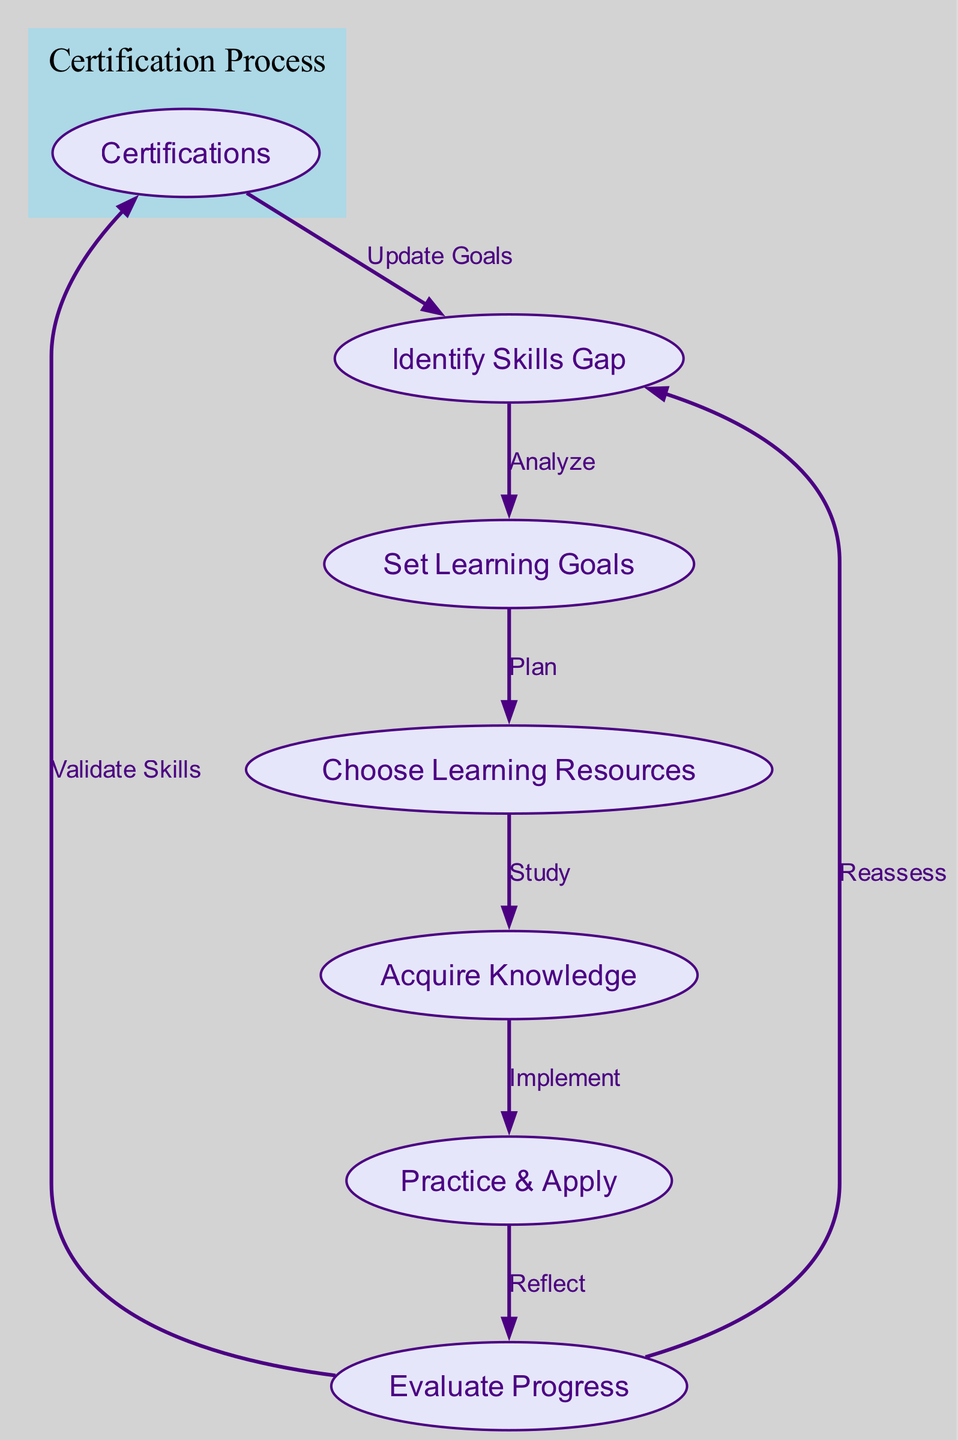What is the first step in the learning cycle? The first step in the cycle is "Identify Skills Gap," which indicates the starting point for any learning process. This is clearly shown as the first node in the diagram.
Answer: Identify Skills Gap How many nodes are there in the diagram? The diagram contains seven nodes, which represent different stages in the continuous learning cycle. This can be counted in the data provided under the "nodes" section.
Answer: Seven What relationship exists between "Set Learning Goals" and "Choose Learning Resources"? The relationship is labeled "Plan," indicating that after setting learning goals, the next step is to choose appropriate learning resources. This shows a direct flow from one node to the next in the context of learning.
Answer: Plan Which node follows "Practice & Apply"? "Evaluate Progress" follows "Practice & Apply." This means that after applying knowledge, the next step is to evaluate how well the knowledge was integrated and practiced, as indicated by the edge connecting these two nodes.
Answer: Evaluate Progress What is the purpose of the "Validate Skills" step? The purpose of the "Validate Skills" step is to confirm the skills acquired through the learning process by achieving certifications, as indicated by the edge leading from "Evaluate Progress" to "Certifications."
Answer: Confirm skills How does the process cycle back from "Evaluate Progress"? The process cycles back to "Identify Skills Gap," indicating that after evaluating progress, IT professionals should reassess their skills needs and potentially identify new gaps, prompting a new cycle of learning.
Answer: Reassess skills What label is used for the relationship between "Certifications" and "Identify Skills Gap"? The label used is "Update Goals," indicating that once certifications are obtained, individuals can revisit and possibly update their learning goals based on their validated skills and market demands.
Answer: Update Goals What action is required after "Acquire Knowledge"? The action required is "Practice & Apply," which emphasizes the importance of not just gaining knowledge but also putting it into practice to solidify learning and understanding. This indicates a sequential action in the learning process.
Answer: Practice & Apply 